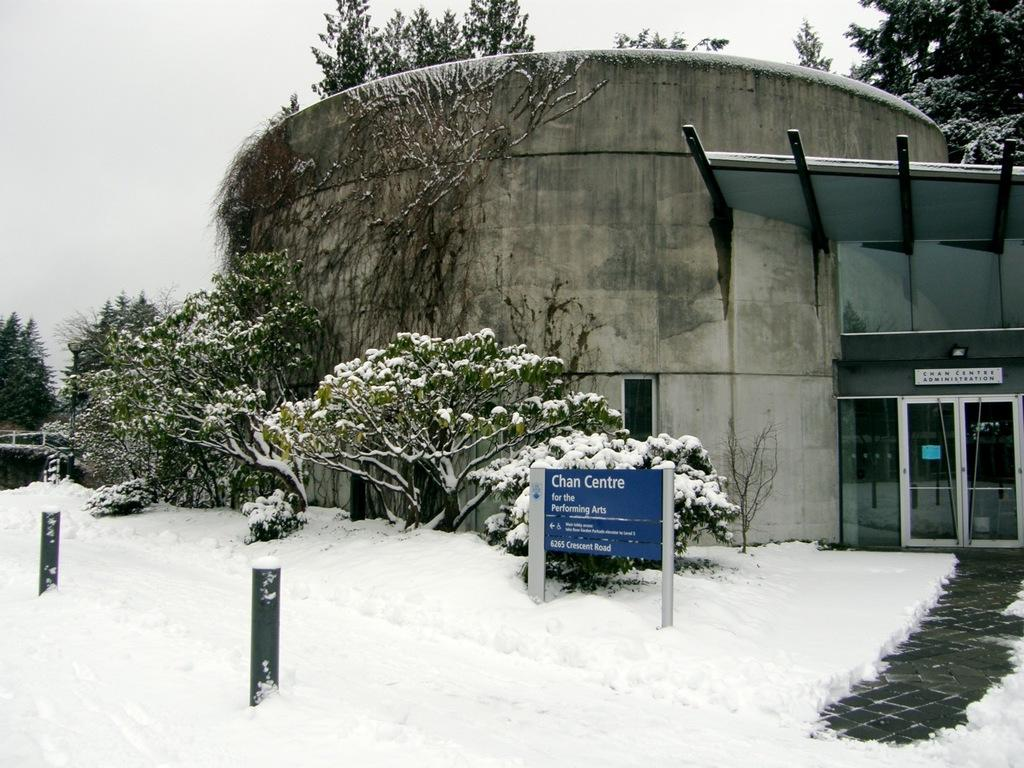What is present in the foreground of the image? In the foreground of the image, there is snow, bollards, trees, and a building. Can you describe the path visible in the image? There is a path on the right side of the image. What can be seen in the background of the image? In the background of the image, there are trees and the sky. What type of harmony is being played on the guitar in the image? There is no guitar or harmony present in the image. What is the end goal of the snow in the image? The snow in the image is not pursuing a goal; it is a natural element in the scene. 